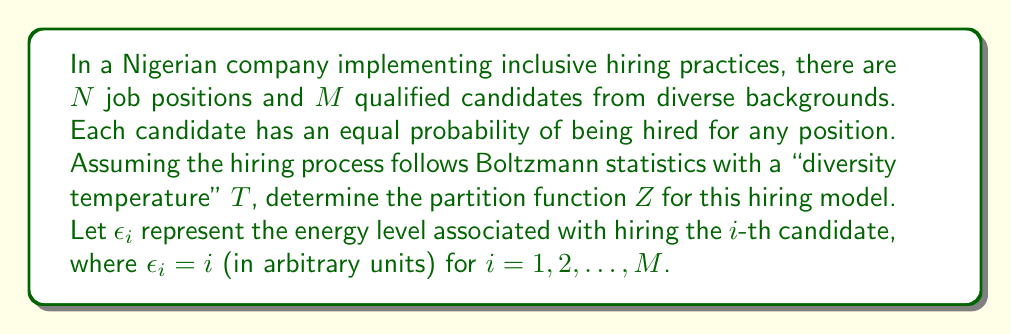Help me with this question. To determine the partition function for this model, we'll follow these steps:

1) The partition function $Z$ is defined as the sum over all possible states of the system:

   $$Z = \sum_{\text{all states}} e^{-\beta E_{\text{state}}}$$

   where $\beta = \frac{1}{k_B T}$, $k_B$ is Boltzmann's constant, and $T$ is the "diversity temperature".

2) In this case, each state represents a particular hiring configuration. The energy of a state is the sum of the energies of the hired candidates.

3) Since each position can be filled by any of the $M$ candidates, and there are $N$ positions, the total number of possible states is $M^N$.

4) The energy of each state is $E_{\text{state}} = \sum_{j=1}^N \epsilon_{i_j}$, where $i_j$ is the index of the candidate hired for the $j$-th position.

5) Therefore, the partition function can be written as:

   $$Z = \sum_{i_1=1}^M \sum_{i_2=1}^M ... \sum_{i_N=1}^M e^{-\beta (\epsilon_{i_1} + \epsilon_{i_2} + ... + \epsilon_{i_N})}$$

6) Since $\epsilon_i = i$, we can rewrite this as:

   $$Z = \sum_{i_1=1}^M \sum_{i_2=1}^M ... \sum_{i_N=1}^M e^{-\beta (i_1 + i_2 + ... + i_N)}$$

7) Due to the exponential property $e^{a+b} = e^a e^b$, this can be factored:

   $$Z = \sum_{i_1=1}^M e^{-\beta i_1} \sum_{i_2=1}^M e^{-\beta i_2} ... \sum_{i_N=1}^M e^{-\beta i_N}$$

8) Each sum is identical, so we can simplify:

   $$Z = \left(\sum_{i=1}^M e^{-\beta i}\right)^N$$

9) The sum inside the parentheses is a geometric series with $M$ terms, first term $a=e^{-\beta}$, and common ratio $r=e^{-\beta}$. The sum of such a series is given by $\frac{a(1-r^M)}{1-r}$.

10) Applying this formula:

    $$Z = \left(\frac{e^{-\beta}(1-e^{-\beta M})}{1-e^{-\beta}}\right)^N$$

This is the final form of the partition function for the given model.
Answer: $$Z = \left(\frac{e^{-\beta}(1-e^{-\beta M})}{1-e^{-\beta}}\right)^N$$ 